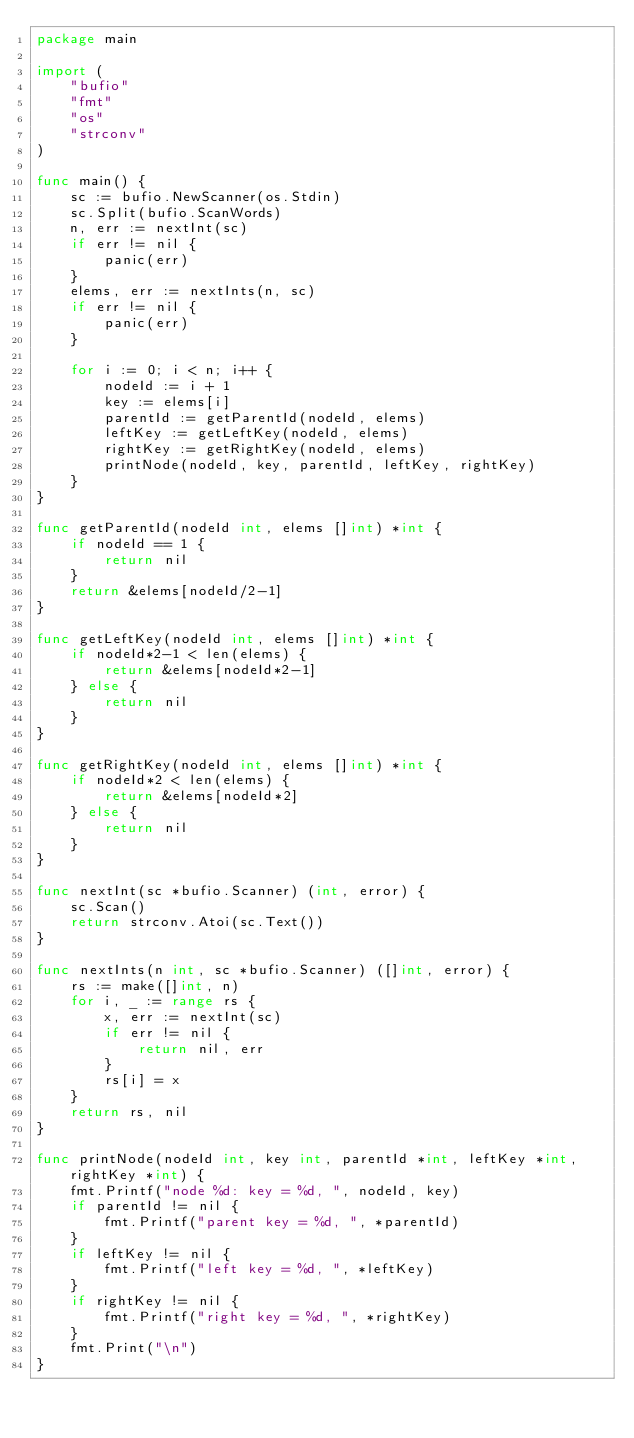<code> <loc_0><loc_0><loc_500><loc_500><_Go_>package main

import (
	"bufio"
	"fmt"
	"os"
	"strconv"
)

func main() {
	sc := bufio.NewScanner(os.Stdin)
	sc.Split(bufio.ScanWords)
	n, err := nextInt(sc)
	if err != nil {
		panic(err)
	}
	elems, err := nextInts(n, sc)
	if err != nil {
		panic(err)
	}

	for i := 0; i < n; i++ {
		nodeId := i + 1
		key := elems[i]
		parentId := getParentId(nodeId, elems)
		leftKey := getLeftKey(nodeId, elems)
		rightKey := getRightKey(nodeId, elems)
		printNode(nodeId, key, parentId, leftKey, rightKey)
	}
}

func getParentId(nodeId int, elems []int) *int {
	if nodeId == 1 {
		return nil
	}
	return &elems[nodeId/2-1]
}

func getLeftKey(nodeId int, elems []int) *int {
	if nodeId*2-1 < len(elems) {
		return &elems[nodeId*2-1]
	} else {
		return nil
	}
}

func getRightKey(nodeId int, elems []int) *int {
	if nodeId*2 < len(elems) {
		return &elems[nodeId*2]
	} else {
		return nil
	}
}

func nextInt(sc *bufio.Scanner) (int, error) {
	sc.Scan()
	return strconv.Atoi(sc.Text())
}

func nextInts(n int, sc *bufio.Scanner) ([]int, error) {
	rs := make([]int, n)
	for i, _ := range rs {
		x, err := nextInt(sc)
		if err != nil {
			return nil, err
		}
		rs[i] = x
	}
	return rs, nil
}

func printNode(nodeId int, key int, parentId *int, leftKey *int, rightKey *int) {
	fmt.Printf("node %d: key = %d, ", nodeId, key)
	if parentId != nil {
		fmt.Printf("parent key = %d, ", *parentId)
	}
	if leftKey != nil {
		fmt.Printf("left key = %d, ", *leftKey)
	}
	if rightKey != nil {
		fmt.Printf("right key = %d, ", *rightKey)
	}
	fmt.Print("\n")
}

</code> 